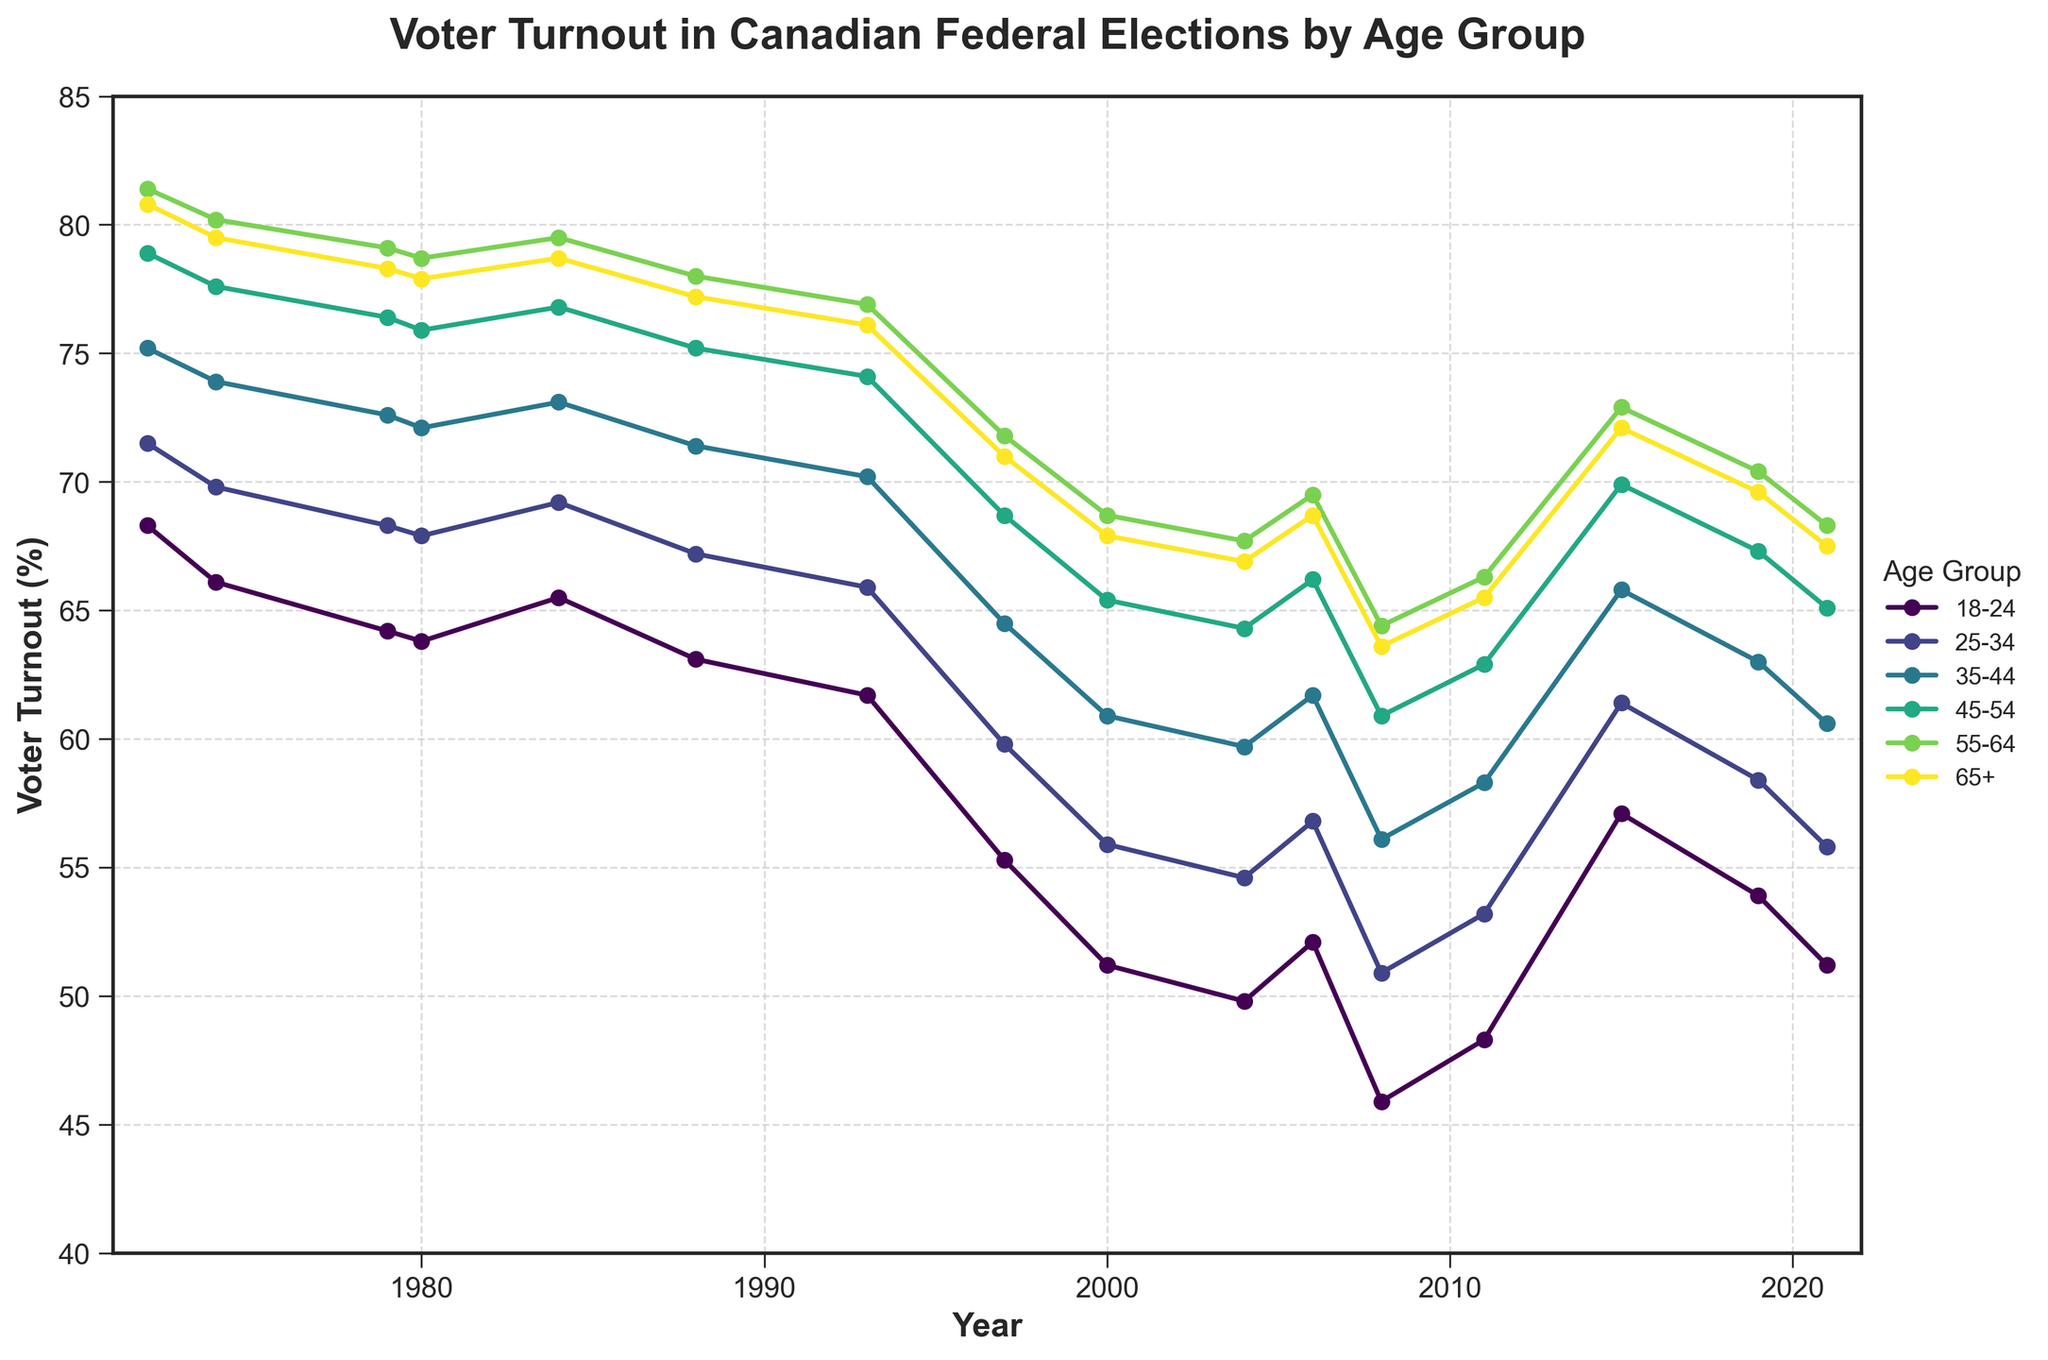What age group had the highest voter turnout in 1984? Look at the data points for the year 1984 and compare the values for each age group. The highest value corresponds to the 55-64 age group with 79.5%.
Answer: 55-64 Did voter turnout increase or decrease for the 25-34 age group from 1972 to 2021? Check the value for the 25-34 age group in 1972 (71.5%) and compare it to the value in 2021 (55.8%). The turnout decreased.
Answer: Decrease How does the voter turnout trend for the 18-24 age group compare to the 65+ age group over these 50 years? Observe the trends of both age groups on the plot. The turnout for the 18-24 age group consistently decreases until around 2015 where it starts to increase, while the 65+ age group remains relatively stable with slight fluctuations.
Answer: 18-24 decreased then increased, 65+ relatively stable What was the voter turnout difference between the 35-44 and 55-64 age groups in 1980? Find the turnout values in 1980 for the 35-44 age group (72.1%) and the 55-64 age group (78.7%) and compute the difference: 78.7 - 72.1 = 6.6%.
Answer: 6.6% Which age group experienced the lowest voter turnout in 2008? Look at the data points for 2008 and identify the lowest value among all age groups, which is for the 18-24 age group at 45.9%.
Answer: 18-24 By how many percentage points did voter turnout change for the 45-54 age group from 1993 to 1997? Compare the voter turnout values in 1993 (74.1%) and 1997 (68.7%) for the 45-54 age group. The difference is 74.1 - 68.7 = 5.4%.
Answer: 5.4% Are there any years where all age groups showed an increase in voter turnout compared to the previous election? Observe the data points year by year to find any year where every age group shows an increase compared to the previous year. In 2015, all age groups have increased voter turnout compared to 2011.
Answer: 2015 What is the average voter turnout for the 35-44 age group across all years? Sum the voter turnout values for the 35-44 age group across all years and divide by the number of years (16). The average is (75.2 + 73.9 + 72.6 + 72.1 + 73.1 + 71.4 + 70.2 + 64.5 + 60.9 + 59.7 + 61.7 + 56.1 + 58.3 + 65.8 + 63.0 + 60.6) / 16 ≈ 66.4%.
Answer: 66.4% Which age group had the most significant decline in voter turnout from 1972 to 2000? Check the turnout for each age group in 1972 and 2000, and calculate the decline. The 18-24 age group started at 68.3% and dropped to 51.2%, a 17.1% decline—the most significant.
Answer: 18-24 How many age groups had a voter turnout higher than 70% in 1988? Observe the 1988 data for the age groups and count the number of groups with values higher than 70%: 45-54 (75.2%), 55-64 (78.0%), and 65+ (77.2%). Only these three meet the criteria.
Answer: 3 